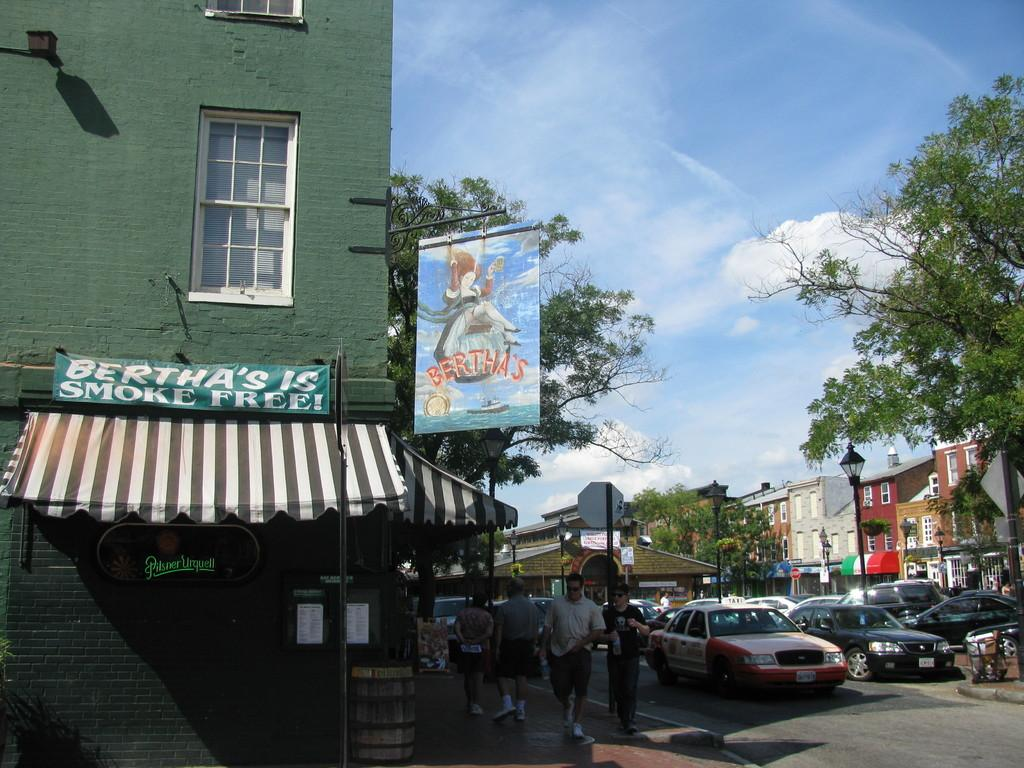<image>
Share a concise interpretation of the image provided. The sign for Bertha's features a woman on a swing. 